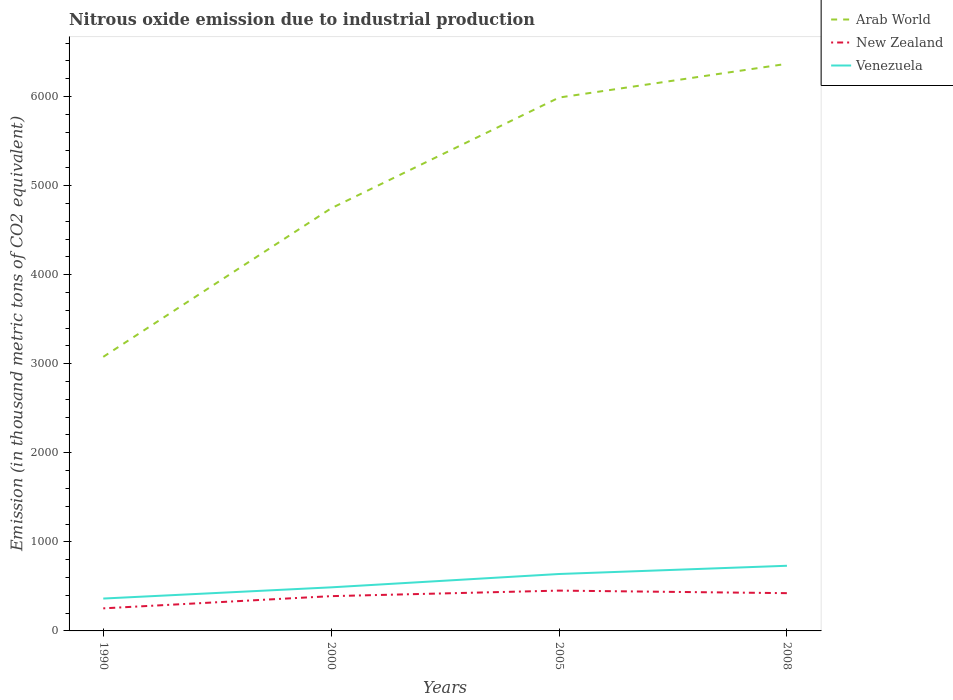How many different coloured lines are there?
Your answer should be compact. 3. Does the line corresponding to New Zealand intersect with the line corresponding to Arab World?
Offer a terse response. No. Across all years, what is the maximum amount of nitrous oxide emitted in Arab World?
Your response must be concise. 3077.4. What is the total amount of nitrous oxide emitted in Arab World in the graph?
Provide a short and direct response. -3290.7. What is the difference between the highest and the second highest amount of nitrous oxide emitted in Venezuela?
Offer a terse response. 368. Is the amount of nitrous oxide emitted in Arab World strictly greater than the amount of nitrous oxide emitted in Venezuela over the years?
Provide a short and direct response. No. How many lines are there?
Keep it short and to the point. 3. How many years are there in the graph?
Your answer should be very brief. 4. What is the difference between two consecutive major ticks on the Y-axis?
Give a very brief answer. 1000. Does the graph contain any zero values?
Ensure brevity in your answer.  No. How many legend labels are there?
Offer a very short reply. 3. What is the title of the graph?
Provide a succinct answer. Nitrous oxide emission due to industrial production. Does "Heavily indebted poor countries" appear as one of the legend labels in the graph?
Offer a very short reply. No. What is the label or title of the Y-axis?
Your answer should be compact. Emission (in thousand metric tons of CO2 equivalent). What is the Emission (in thousand metric tons of CO2 equivalent) in Arab World in 1990?
Your answer should be compact. 3077.4. What is the Emission (in thousand metric tons of CO2 equivalent) of New Zealand in 1990?
Offer a terse response. 253.4. What is the Emission (in thousand metric tons of CO2 equivalent) in Venezuela in 1990?
Provide a short and direct response. 363.6. What is the Emission (in thousand metric tons of CO2 equivalent) of Arab World in 2000?
Your answer should be very brief. 4745.5. What is the Emission (in thousand metric tons of CO2 equivalent) of New Zealand in 2000?
Offer a terse response. 390.5. What is the Emission (in thousand metric tons of CO2 equivalent) of Venezuela in 2000?
Offer a very short reply. 489.3. What is the Emission (in thousand metric tons of CO2 equivalent) in Arab World in 2005?
Give a very brief answer. 5989.1. What is the Emission (in thousand metric tons of CO2 equivalent) in New Zealand in 2005?
Offer a very short reply. 452.7. What is the Emission (in thousand metric tons of CO2 equivalent) in Venezuela in 2005?
Offer a very short reply. 639.1. What is the Emission (in thousand metric tons of CO2 equivalent) in Arab World in 2008?
Make the answer very short. 6368.1. What is the Emission (in thousand metric tons of CO2 equivalent) of New Zealand in 2008?
Provide a short and direct response. 424. What is the Emission (in thousand metric tons of CO2 equivalent) of Venezuela in 2008?
Offer a terse response. 731.6. Across all years, what is the maximum Emission (in thousand metric tons of CO2 equivalent) of Arab World?
Ensure brevity in your answer.  6368.1. Across all years, what is the maximum Emission (in thousand metric tons of CO2 equivalent) of New Zealand?
Your answer should be very brief. 452.7. Across all years, what is the maximum Emission (in thousand metric tons of CO2 equivalent) in Venezuela?
Keep it short and to the point. 731.6. Across all years, what is the minimum Emission (in thousand metric tons of CO2 equivalent) of Arab World?
Your answer should be very brief. 3077.4. Across all years, what is the minimum Emission (in thousand metric tons of CO2 equivalent) in New Zealand?
Provide a short and direct response. 253.4. Across all years, what is the minimum Emission (in thousand metric tons of CO2 equivalent) in Venezuela?
Ensure brevity in your answer.  363.6. What is the total Emission (in thousand metric tons of CO2 equivalent) in Arab World in the graph?
Your response must be concise. 2.02e+04. What is the total Emission (in thousand metric tons of CO2 equivalent) of New Zealand in the graph?
Your response must be concise. 1520.6. What is the total Emission (in thousand metric tons of CO2 equivalent) in Venezuela in the graph?
Provide a succinct answer. 2223.6. What is the difference between the Emission (in thousand metric tons of CO2 equivalent) in Arab World in 1990 and that in 2000?
Your answer should be very brief. -1668.1. What is the difference between the Emission (in thousand metric tons of CO2 equivalent) in New Zealand in 1990 and that in 2000?
Your answer should be compact. -137.1. What is the difference between the Emission (in thousand metric tons of CO2 equivalent) in Venezuela in 1990 and that in 2000?
Your answer should be very brief. -125.7. What is the difference between the Emission (in thousand metric tons of CO2 equivalent) in Arab World in 1990 and that in 2005?
Ensure brevity in your answer.  -2911.7. What is the difference between the Emission (in thousand metric tons of CO2 equivalent) of New Zealand in 1990 and that in 2005?
Your response must be concise. -199.3. What is the difference between the Emission (in thousand metric tons of CO2 equivalent) of Venezuela in 1990 and that in 2005?
Ensure brevity in your answer.  -275.5. What is the difference between the Emission (in thousand metric tons of CO2 equivalent) in Arab World in 1990 and that in 2008?
Your answer should be very brief. -3290.7. What is the difference between the Emission (in thousand metric tons of CO2 equivalent) in New Zealand in 1990 and that in 2008?
Your response must be concise. -170.6. What is the difference between the Emission (in thousand metric tons of CO2 equivalent) in Venezuela in 1990 and that in 2008?
Keep it short and to the point. -368. What is the difference between the Emission (in thousand metric tons of CO2 equivalent) of Arab World in 2000 and that in 2005?
Your answer should be very brief. -1243.6. What is the difference between the Emission (in thousand metric tons of CO2 equivalent) of New Zealand in 2000 and that in 2005?
Keep it short and to the point. -62.2. What is the difference between the Emission (in thousand metric tons of CO2 equivalent) of Venezuela in 2000 and that in 2005?
Provide a succinct answer. -149.8. What is the difference between the Emission (in thousand metric tons of CO2 equivalent) in Arab World in 2000 and that in 2008?
Provide a short and direct response. -1622.6. What is the difference between the Emission (in thousand metric tons of CO2 equivalent) of New Zealand in 2000 and that in 2008?
Your response must be concise. -33.5. What is the difference between the Emission (in thousand metric tons of CO2 equivalent) of Venezuela in 2000 and that in 2008?
Give a very brief answer. -242.3. What is the difference between the Emission (in thousand metric tons of CO2 equivalent) of Arab World in 2005 and that in 2008?
Ensure brevity in your answer.  -379. What is the difference between the Emission (in thousand metric tons of CO2 equivalent) in New Zealand in 2005 and that in 2008?
Give a very brief answer. 28.7. What is the difference between the Emission (in thousand metric tons of CO2 equivalent) of Venezuela in 2005 and that in 2008?
Provide a succinct answer. -92.5. What is the difference between the Emission (in thousand metric tons of CO2 equivalent) of Arab World in 1990 and the Emission (in thousand metric tons of CO2 equivalent) of New Zealand in 2000?
Make the answer very short. 2686.9. What is the difference between the Emission (in thousand metric tons of CO2 equivalent) in Arab World in 1990 and the Emission (in thousand metric tons of CO2 equivalent) in Venezuela in 2000?
Your answer should be compact. 2588.1. What is the difference between the Emission (in thousand metric tons of CO2 equivalent) in New Zealand in 1990 and the Emission (in thousand metric tons of CO2 equivalent) in Venezuela in 2000?
Give a very brief answer. -235.9. What is the difference between the Emission (in thousand metric tons of CO2 equivalent) in Arab World in 1990 and the Emission (in thousand metric tons of CO2 equivalent) in New Zealand in 2005?
Provide a short and direct response. 2624.7. What is the difference between the Emission (in thousand metric tons of CO2 equivalent) of Arab World in 1990 and the Emission (in thousand metric tons of CO2 equivalent) of Venezuela in 2005?
Provide a short and direct response. 2438.3. What is the difference between the Emission (in thousand metric tons of CO2 equivalent) in New Zealand in 1990 and the Emission (in thousand metric tons of CO2 equivalent) in Venezuela in 2005?
Give a very brief answer. -385.7. What is the difference between the Emission (in thousand metric tons of CO2 equivalent) in Arab World in 1990 and the Emission (in thousand metric tons of CO2 equivalent) in New Zealand in 2008?
Ensure brevity in your answer.  2653.4. What is the difference between the Emission (in thousand metric tons of CO2 equivalent) in Arab World in 1990 and the Emission (in thousand metric tons of CO2 equivalent) in Venezuela in 2008?
Provide a short and direct response. 2345.8. What is the difference between the Emission (in thousand metric tons of CO2 equivalent) in New Zealand in 1990 and the Emission (in thousand metric tons of CO2 equivalent) in Venezuela in 2008?
Provide a succinct answer. -478.2. What is the difference between the Emission (in thousand metric tons of CO2 equivalent) in Arab World in 2000 and the Emission (in thousand metric tons of CO2 equivalent) in New Zealand in 2005?
Provide a succinct answer. 4292.8. What is the difference between the Emission (in thousand metric tons of CO2 equivalent) in Arab World in 2000 and the Emission (in thousand metric tons of CO2 equivalent) in Venezuela in 2005?
Your response must be concise. 4106.4. What is the difference between the Emission (in thousand metric tons of CO2 equivalent) of New Zealand in 2000 and the Emission (in thousand metric tons of CO2 equivalent) of Venezuela in 2005?
Make the answer very short. -248.6. What is the difference between the Emission (in thousand metric tons of CO2 equivalent) in Arab World in 2000 and the Emission (in thousand metric tons of CO2 equivalent) in New Zealand in 2008?
Offer a terse response. 4321.5. What is the difference between the Emission (in thousand metric tons of CO2 equivalent) of Arab World in 2000 and the Emission (in thousand metric tons of CO2 equivalent) of Venezuela in 2008?
Make the answer very short. 4013.9. What is the difference between the Emission (in thousand metric tons of CO2 equivalent) in New Zealand in 2000 and the Emission (in thousand metric tons of CO2 equivalent) in Venezuela in 2008?
Offer a very short reply. -341.1. What is the difference between the Emission (in thousand metric tons of CO2 equivalent) of Arab World in 2005 and the Emission (in thousand metric tons of CO2 equivalent) of New Zealand in 2008?
Your answer should be compact. 5565.1. What is the difference between the Emission (in thousand metric tons of CO2 equivalent) of Arab World in 2005 and the Emission (in thousand metric tons of CO2 equivalent) of Venezuela in 2008?
Provide a short and direct response. 5257.5. What is the difference between the Emission (in thousand metric tons of CO2 equivalent) in New Zealand in 2005 and the Emission (in thousand metric tons of CO2 equivalent) in Venezuela in 2008?
Your answer should be very brief. -278.9. What is the average Emission (in thousand metric tons of CO2 equivalent) of Arab World per year?
Provide a short and direct response. 5045.02. What is the average Emission (in thousand metric tons of CO2 equivalent) in New Zealand per year?
Provide a succinct answer. 380.15. What is the average Emission (in thousand metric tons of CO2 equivalent) in Venezuela per year?
Ensure brevity in your answer.  555.9. In the year 1990, what is the difference between the Emission (in thousand metric tons of CO2 equivalent) of Arab World and Emission (in thousand metric tons of CO2 equivalent) of New Zealand?
Provide a short and direct response. 2824. In the year 1990, what is the difference between the Emission (in thousand metric tons of CO2 equivalent) of Arab World and Emission (in thousand metric tons of CO2 equivalent) of Venezuela?
Provide a succinct answer. 2713.8. In the year 1990, what is the difference between the Emission (in thousand metric tons of CO2 equivalent) of New Zealand and Emission (in thousand metric tons of CO2 equivalent) of Venezuela?
Your answer should be compact. -110.2. In the year 2000, what is the difference between the Emission (in thousand metric tons of CO2 equivalent) of Arab World and Emission (in thousand metric tons of CO2 equivalent) of New Zealand?
Offer a very short reply. 4355. In the year 2000, what is the difference between the Emission (in thousand metric tons of CO2 equivalent) in Arab World and Emission (in thousand metric tons of CO2 equivalent) in Venezuela?
Offer a terse response. 4256.2. In the year 2000, what is the difference between the Emission (in thousand metric tons of CO2 equivalent) in New Zealand and Emission (in thousand metric tons of CO2 equivalent) in Venezuela?
Your answer should be compact. -98.8. In the year 2005, what is the difference between the Emission (in thousand metric tons of CO2 equivalent) of Arab World and Emission (in thousand metric tons of CO2 equivalent) of New Zealand?
Give a very brief answer. 5536.4. In the year 2005, what is the difference between the Emission (in thousand metric tons of CO2 equivalent) in Arab World and Emission (in thousand metric tons of CO2 equivalent) in Venezuela?
Give a very brief answer. 5350. In the year 2005, what is the difference between the Emission (in thousand metric tons of CO2 equivalent) of New Zealand and Emission (in thousand metric tons of CO2 equivalent) of Venezuela?
Provide a short and direct response. -186.4. In the year 2008, what is the difference between the Emission (in thousand metric tons of CO2 equivalent) in Arab World and Emission (in thousand metric tons of CO2 equivalent) in New Zealand?
Your answer should be very brief. 5944.1. In the year 2008, what is the difference between the Emission (in thousand metric tons of CO2 equivalent) in Arab World and Emission (in thousand metric tons of CO2 equivalent) in Venezuela?
Your answer should be very brief. 5636.5. In the year 2008, what is the difference between the Emission (in thousand metric tons of CO2 equivalent) in New Zealand and Emission (in thousand metric tons of CO2 equivalent) in Venezuela?
Keep it short and to the point. -307.6. What is the ratio of the Emission (in thousand metric tons of CO2 equivalent) in Arab World in 1990 to that in 2000?
Provide a succinct answer. 0.65. What is the ratio of the Emission (in thousand metric tons of CO2 equivalent) in New Zealand in 1990 to that in 2000?
Your answer should be very brief. 0.65. What is the ratio of the Emission (in thousand metric tons of CO2 equivalent) of Venezuela in 1990 to that in 2000?
Make the answer very short. 0.74. What is the ratio of the Emission (in thousand metric tons of CO2 equivalent) in Arab World in 1990 to that in 2005?
Ensure brevity in your answer.  0.51. What is the ratio of the Emission (in thousand metric tons of CO2 equivalent) in New Zealand in 1990 to that in 2005?
Provide a short and direct response. 0.56. What is the ratio of the Emission (in thousand metric tons of CO2 equivalent) in Venezuela in 1990 to that in 2005?
Your response must be concise. 0.57. What is the ratio of the Emission (in thousand metric tons of CO2 equivalent) in Arab World in 1990 to that in 2008?
Make the answer very short. 0.48. What is the ratio of the Emission (in thousand metric tons of CO2 equivalent) of New Zealand in 1990 to that in 2008?
Your response must be concise. 0.6. What is the ratio of the Emission (in thousand metric tons of CO2 equivalent) in Venezuela in 1990 to that in 2008?
Keep it short and to the point. 0.5. What is the ratio of the Emission (in thousand metric tons of CO2 equivalent) in Arab World in 2000 to that in 2005?
Make the answer very short. 0.79. What is the ratio of the Emission (in thousand metric tons of CO2 equivalent) of New Zealand in 2000 to that in 2005?
Offer a very short reply. 0.86. What is the ratio of the Emission (in thousand metric tons of CO2 equivalent) of Venezuela in 2000 to that in 2005?
Ensure brevity in your answer.  0.77. What is the ratio of the Emission (in thousand metric tons of CO2 equivalent) of Arab World in 2000 to that in 2008?
Provide a succinct answer. 0.75. What is the ratio of the Emission (in thousand metric tons of CO2 equivalent) of New Zealand in 2000 to that in 2008?
Provide a succinct answer. 0.92. What is the ratio of the Emission (in thousand metric tons of CO2 equivalent) in Venezuela in 2000 to that in 2008?
Offer a very short reply. 0.67. What is the ratio of the Emission (in thousand metric tons of CO2 equivalent) in Arab World in 2005 to that in 2008?
Make the answer very short. 0.94. What is the ratio of the Emission (in thousand metric tons of CO2 equivalent) in New Zealand in 2005 to that in 2008?
Give a very brief answer. 1.07. What is the ratio of the Emission (in thousand metric tons of CO2 equivalent) in Venezuela in 2005 to that in 2008?
Offer a terse response. 0.87. What is the difference between the highest and the second highest Emission (in thousand metric tons of CO2 equivalent) in Arab World?
Give a very brief answer. 379. What is the difference between the highest and the second highest Emission (in thousand metric tons of CO2 equivalent) in New Zealand?
Offer a terse response. 28.7. What is the difference between the highest and the second highest Emission (in thousand metric tons of CO2 equivalent) of Venezuela?
Offer a terse response. 92.5. What is the difference between the highest and the lowest Emission (in thousand metric tons of CO2 equivalent) in Arab World?
Offer a terse response. 3290.7. What is the difference between the highest and the lowest Emission (in thousand metric tons of CO2 equivalent) in New Zealand?
Offer a terse response. 199.3. What is the difference between the highest and the lowest Emission (in thousand metric tons of CO2 equivalent) in Venezuela?
Your answer should be compact. 368. 